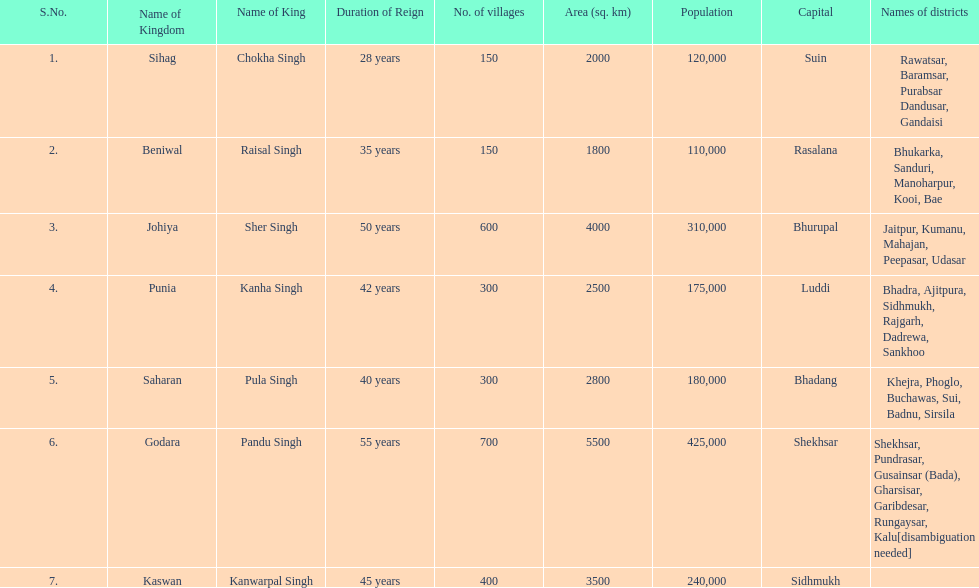As per this chart, what is the quantity of villages in johiya? 600. 